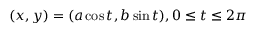<formula> <loc_0><loc_0><loc_500><loc_500>( x , y ) = ( a \cos { t } , b \sin { t } ) , 0 \leq t \leq 2 \pi</formula> 